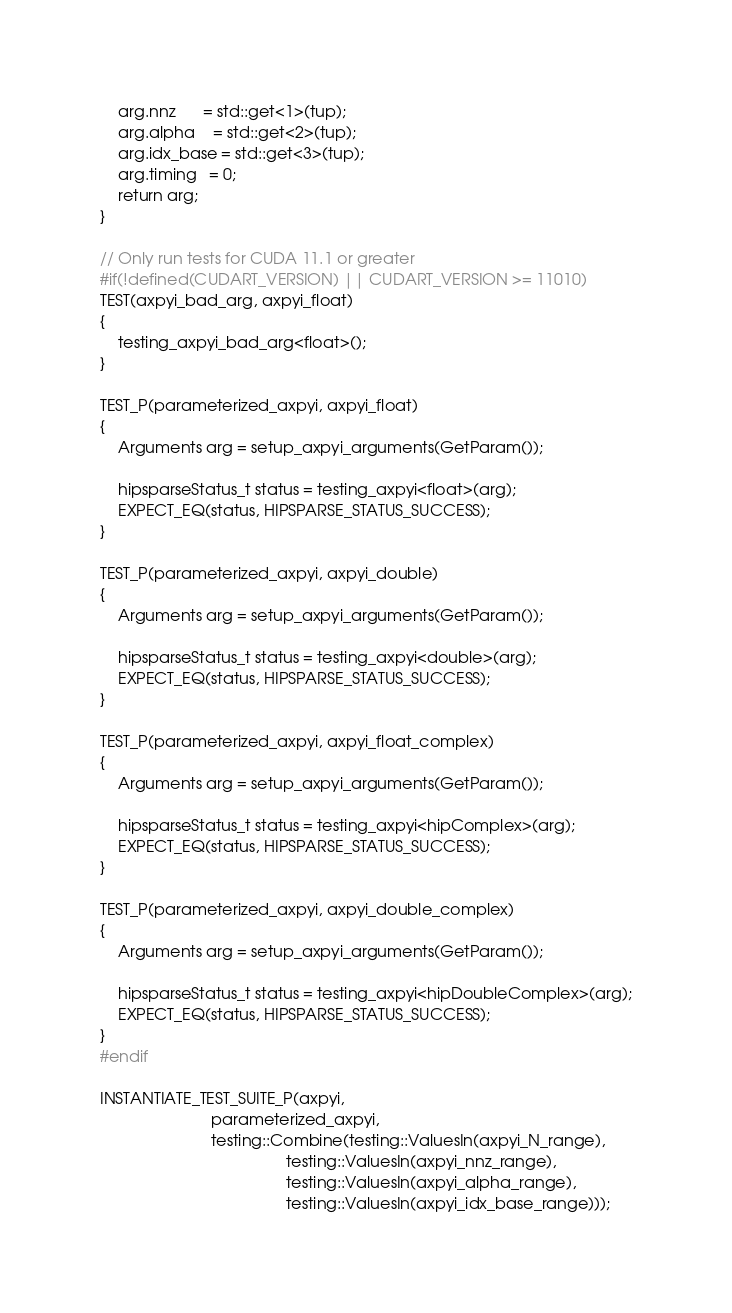Convert code to text. <code><loc_0><loc_0><loc_500><loc_500><_C++_>    arg.nnz      = std::get<1>(tup);
    arg.alpha    = std::get<2>(tup);
    arg.idx_base = std::get<3>(tup);
    arg.timing   = 0;
    return arg;
}

// Only run tests for CUDA 11.1 or greater
#if(!defined(CUDART_VERSION) || CUDART_VERSION >= 11010)
TEST(axpyi_bad_arg, axpyi_float)
{
    testing_axpyi_bad_arg<float>();
}

TEST_P(parameterized_axpyi, axpyi_float)
{
    Arguments arg = setup_axpyi_arguments(GetParam());

    hipsparseStatus_t status = testing_axpyi<float>(arg);
    EXPECT_EQ(status, HIPSPARSE_STATUS_SUCCESS);
}

TEST_P(parameterized_axpyi, axpyi_double)
{
    Arguments arg = setup_axpyi_arguments(GetParam());

    hipsparseStatus_t status = testing_axpyi<double>(arg);
    EXPECT_EQ(status, HIPSPARSE_STATUS_SUCCESS);
}

TEST_P(parameterized_axpyi, axpyi_float_complex)
{
    Arguments arg = setup_axpyi_arguments(GetParam());

    hipsparseStatus_t status = testing_axpyi<hipComplex>(arg);
    EXPECT_EQ(status, HIPSPARSE_STATUS_SUCCESS);
}

TEST_P(parameterized_axpyi, axpyi_double_complex)
{
    Arguments arg = setup_axpyi_arguments(GetParam());

    hipsparseStatus_t status = testing_axpyi<hipDoubleComplex>(arg);
    EXPECT_EQ(status, HIPSPARSE_STATUS_SUCCESS);
}
#endif

INSTANTIATE_TEST_SUITE_P(axpyi,
                         parameterized_axpyi,
                         testing::Combine(testing::ValuesIn(axpyi_N_range),
                                          testing::ValuesIn(axpyi_nnz_range),
                                          testing::ValuesIn(axpyi_alpha_range),
                                          testing::ValuesIn(axpyi_idx_base_range)));
</code> 